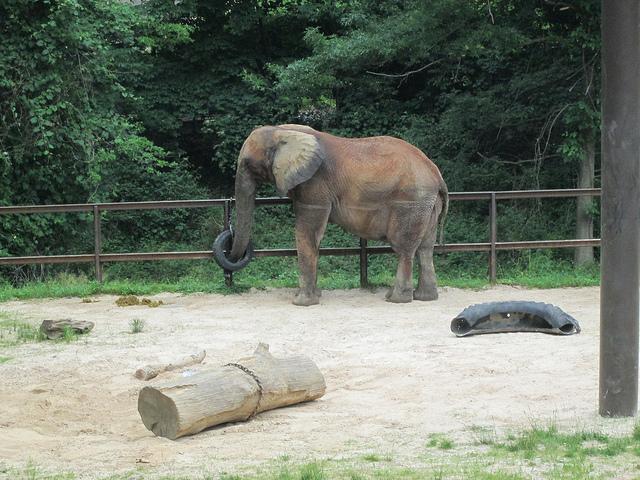Is this in the wild?
Give a very brief answer. No. Is the elephant's trunk in a natural position?
Keep it brief. Yes. Where are the animals going?
Concise answer only. Nowhere. What is next to the elephant?
Give a very brief answer. Fence. What type of elephant is this?
Short answer required. African. Why is this elephant trying to lift the fence with it's trunk?
Concise answer only. To escape. Why is the chain on the log?
Keep it brief. For play. What is the elephant trying to get out of the tire?
Short answer required. Water. 